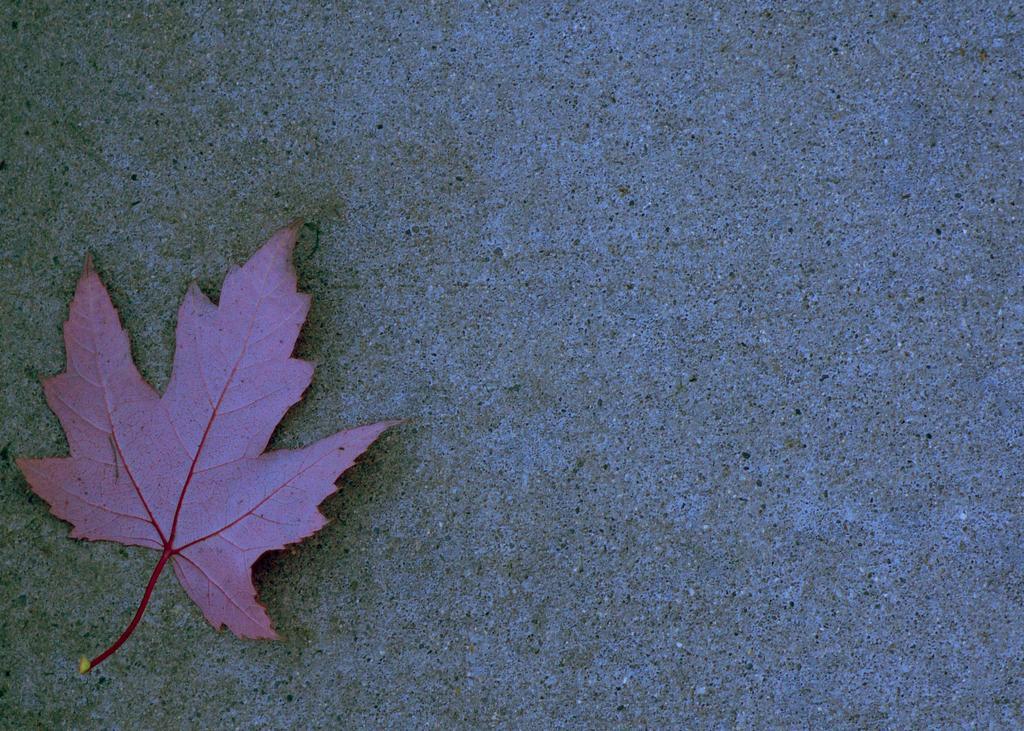How would you summarize this image in a sentence or two? On the left side, we see a leaf in pink or purple color. In the background, we see a wall or the pavement. 